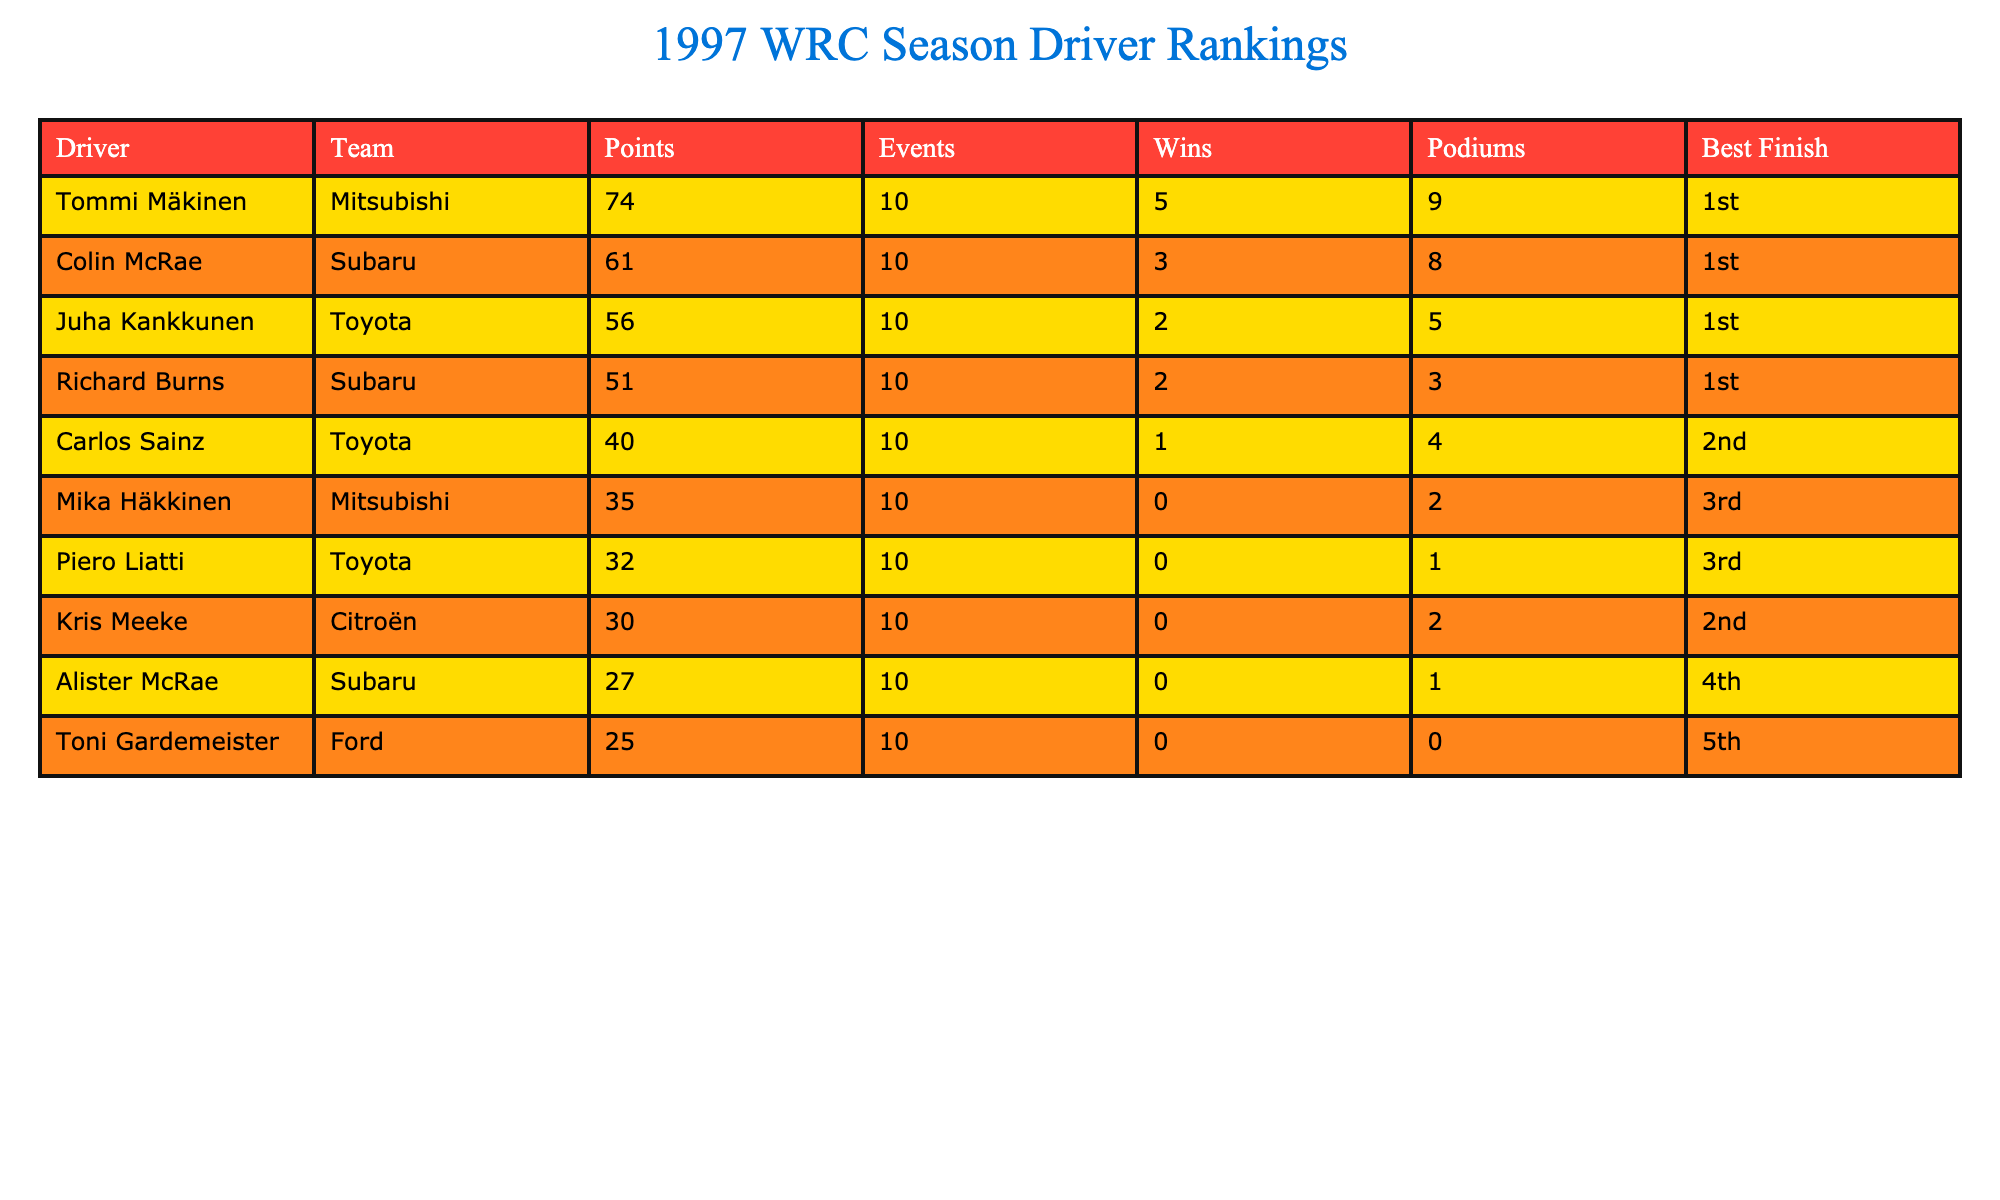What is the total number of wins for all drivers? To find the total number of wins, we add the values from the Wins column: 5 (Tommi Mäkinen) + 3 (Colin McRae) + 2 (Juha Kankkunen) + 2 (Richard Burns) + 1 (Carlos Sainz) + 0 + 0 + 0 + 0 + 0 = 13.
Answer: 13 Which driver achieved the highest podium finishes? The driver with the highest number of podium finishes is Tommi Mäkinen with 9 podiums. We can see that other drivers, like Colin McRae, have 8 podiums but none exceeds 9.
Answer: Tommi Mäkinen How many points did the driver with the least points earn? The driver with the least points is Toni Gardemeister, who earned 25 points. This information is clearly visible in the Points column of the table.
Answer: 25 Is it true that all drivers drove for different teams? No, it is false as several drivers drove for the same team. For instance, Colin McRae and Richard Burns both drove for Subaru, and Juha Kankkunen and Carlos Sainz drove for Toyota.
Answer: False What is the average number of points earned by drivers in the table? To calculate the average points, we first find the total points: 74 + 61 + 56 + 51 + 40 + 35 + 32 + 30 + 27 + 25 =  399. There are 10 drivers, so the average is 399 divided by 10, which equals 39.9.
Answer: 39.9 Which driver finished in 2nd place the most times? Both Colin McRae and Kris Meeke had a best finish of 1st and 2nd, respectively, but Colin McRae is noted for having the best finish more often, thus confirming he's the only one with a first finish and was in 2nd twice.
Answer: Colin McRae How many drivers achieved a best finish of 1st? There are three drivers listed who achieved a best finish of 1st: Tommi Mäkinen, Colin McRae, and Juha Kankkunen. This is found in the Best Finish column where they are marked as 1st.
Answer: 3 What is the difference in points between the top driver and the second driver? The difference is calculated by subtracting the points of the second driver from the top driver's points: Tommi Mäkinen has 74 points, and Colin McRae has 61 points; therefore, 74 - 61 = 13.
Answer: 13 